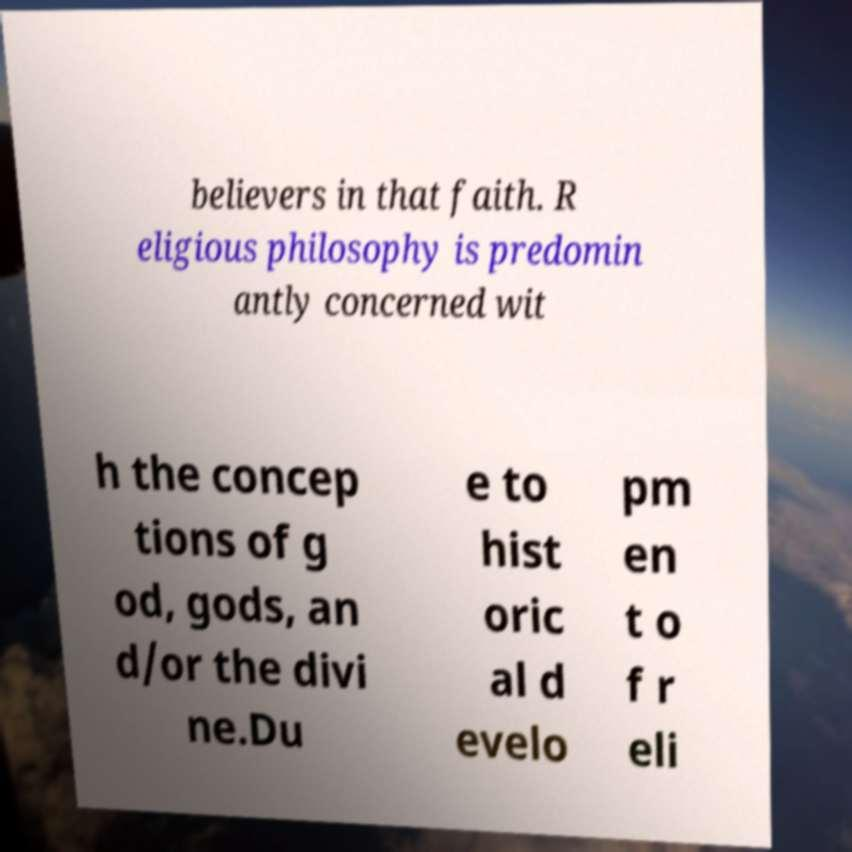I need the written content from this picture converted into text. Can you do that? believers in that faith. R eligious philosophy is predomin antly concerned wit h the concep tions of g od, gods, an d/or the divi ne.Du e to hist oric al d evelo pm en t o f r eli 